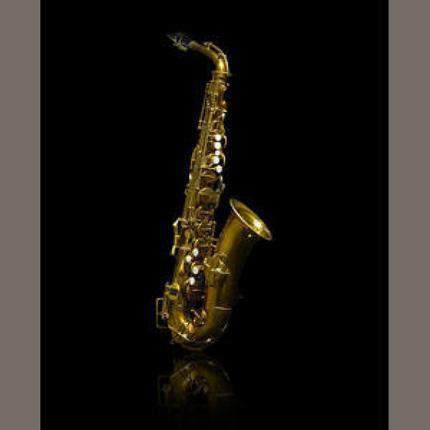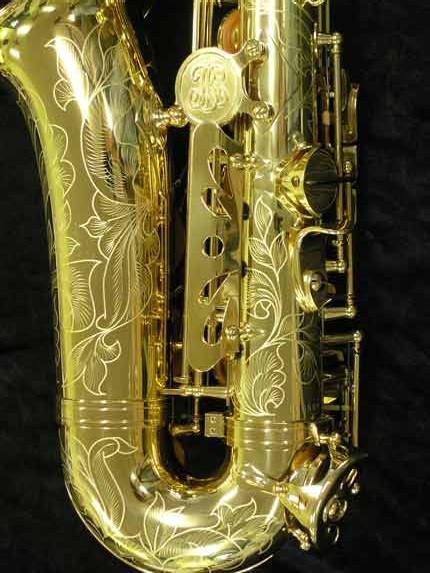The first image is the image on the left, the second image is the image on the right. Evaluate the accuracy of this statement regarding the images: "Each image shows a single saxophone displayed so it is nearly vertical.". Is it true? Answer yes or no. Yes. The first image is the image on the left, the second image is the image on the right. Evaluate the accuracy of this statement regarding the images: "Both saxophones are positioned upright.". Is it true? Answer yes or no. Yes. 